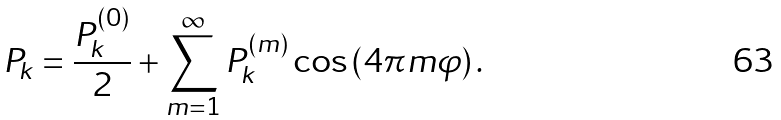Convert formula to latex. <formula><loc_0><loc_0><loc_500><loc_500>P _ { k } = \frac { P ^ { ( 0 ) } _ { k } } { 2 } + \sum _ { m = 1 } ^ { \infty } P ^ { ( m ) } _ { k } \cos { \left ( 4 \pi m \varphi \right ) } \, .</formula> 